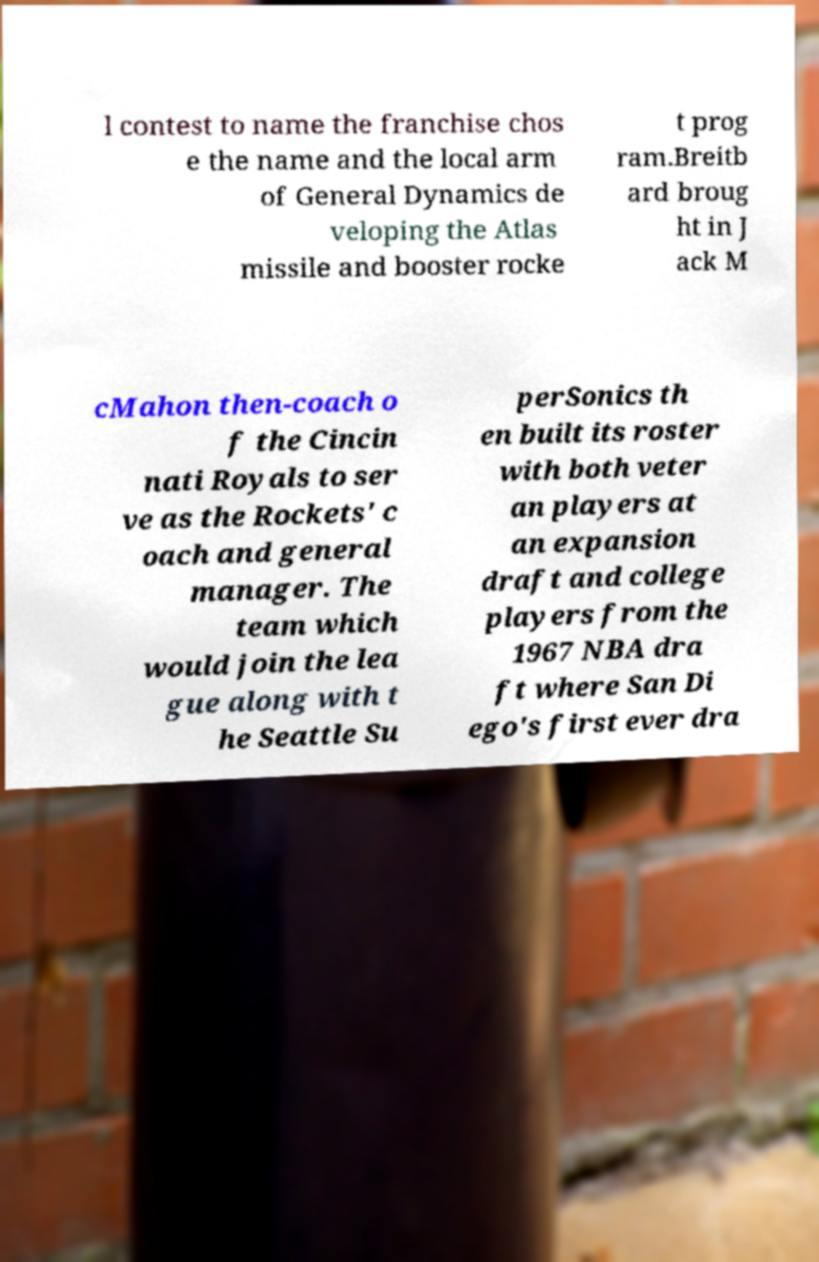Please read and relay the text visible in this image. What does it say? l contest to name the franchise chos e the name and the local arm of General Dynamics de veloping the Atlas missile and booster rocke t prog ram.Breitb ard broug ht in J ack M cMahon then-coach o f the Cincin nati Royals to ser ve as the Rockets' c oach and general manager. The team which would join the lea gue along with t he Seattle Su perSonics th en built its roster with both veter an players at an expansion draft and college players from the 1967 NBA dra ft where San Di ego's first ever dra 